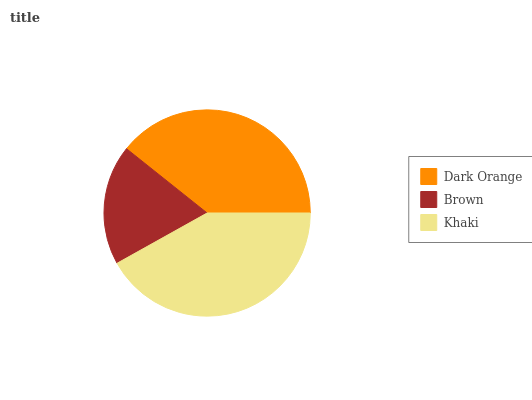Is Brown the minimum?
Answer yes or no. Yes. Is Khaki the maximum?
Answer yes or no. Yes. Is Khaki the minimum?
Answer yes or no. No. Is Brown the maximum?
Answer yes or no. No. Is Khaki greater than Brown?
Answer yes or no. Yes. Is Brown less than Khaki?
Answer yes or no. Yes. Is Brown greater than Khaki?
Answer yes or no. No. Is Khaki less than Brown?
Answer yes or no. No. Is Dark Orange the high median?
Answer yes or no. Yes. Is Dark Orange the low median?
Answer yes or no. Yes. Is Brown the high median?
Answer yes or no. No. Is Khaki the low median?
Answer yes or no. No. 